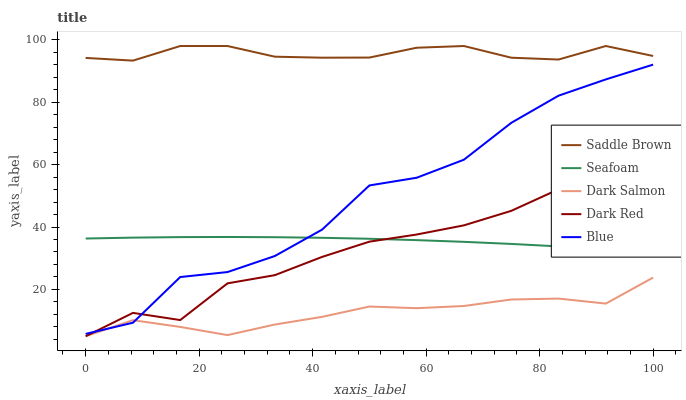Does Dark Salmon have the minimum area under the curve?
Answer yes or no. Yes. Does Saddle Brown have the maximum area under the curve?
Answer yes or no. Yes. Does Dark Red have the minimum area under the curve?
Answer yes or no. No. Does Dark Red have the maximum area under the curve?
Answer yes or no. No. Is Seafoam the smoothest?
Answer yes or no. Yes. Is Blue the roughest?
Answer yes or no. Yes. Is Dark Red the smoothest?
Answer yes or no. No. Is Dark Red the roughest?
Answer yes or no. No. Does Dark Red have the lowest value?
Answer yes or no. Yes. Does Saddle Brown have the lowest value?
Answer yes or no. No. Does Saddle Brown have the highest value?
Answer yes or no. Yes. Does Dark Red have the highest value?
Answer yes or no. No. Is Dark Salmon less than Seafoam?
Answer yes or no. Yes. Is Saddle Brown greater than Dark Salmon?
Answer yes or no. Yes. Does Blue intersect Seafoam?
Answer yes or no. Yes. Is Blue less than Seafoam?
Answer yes or no. No. Is Blue greater than Seafoam?
Answer yes or no. No. Does Dark Salmon intersect Seafoam?
Answer yes or no. No. 